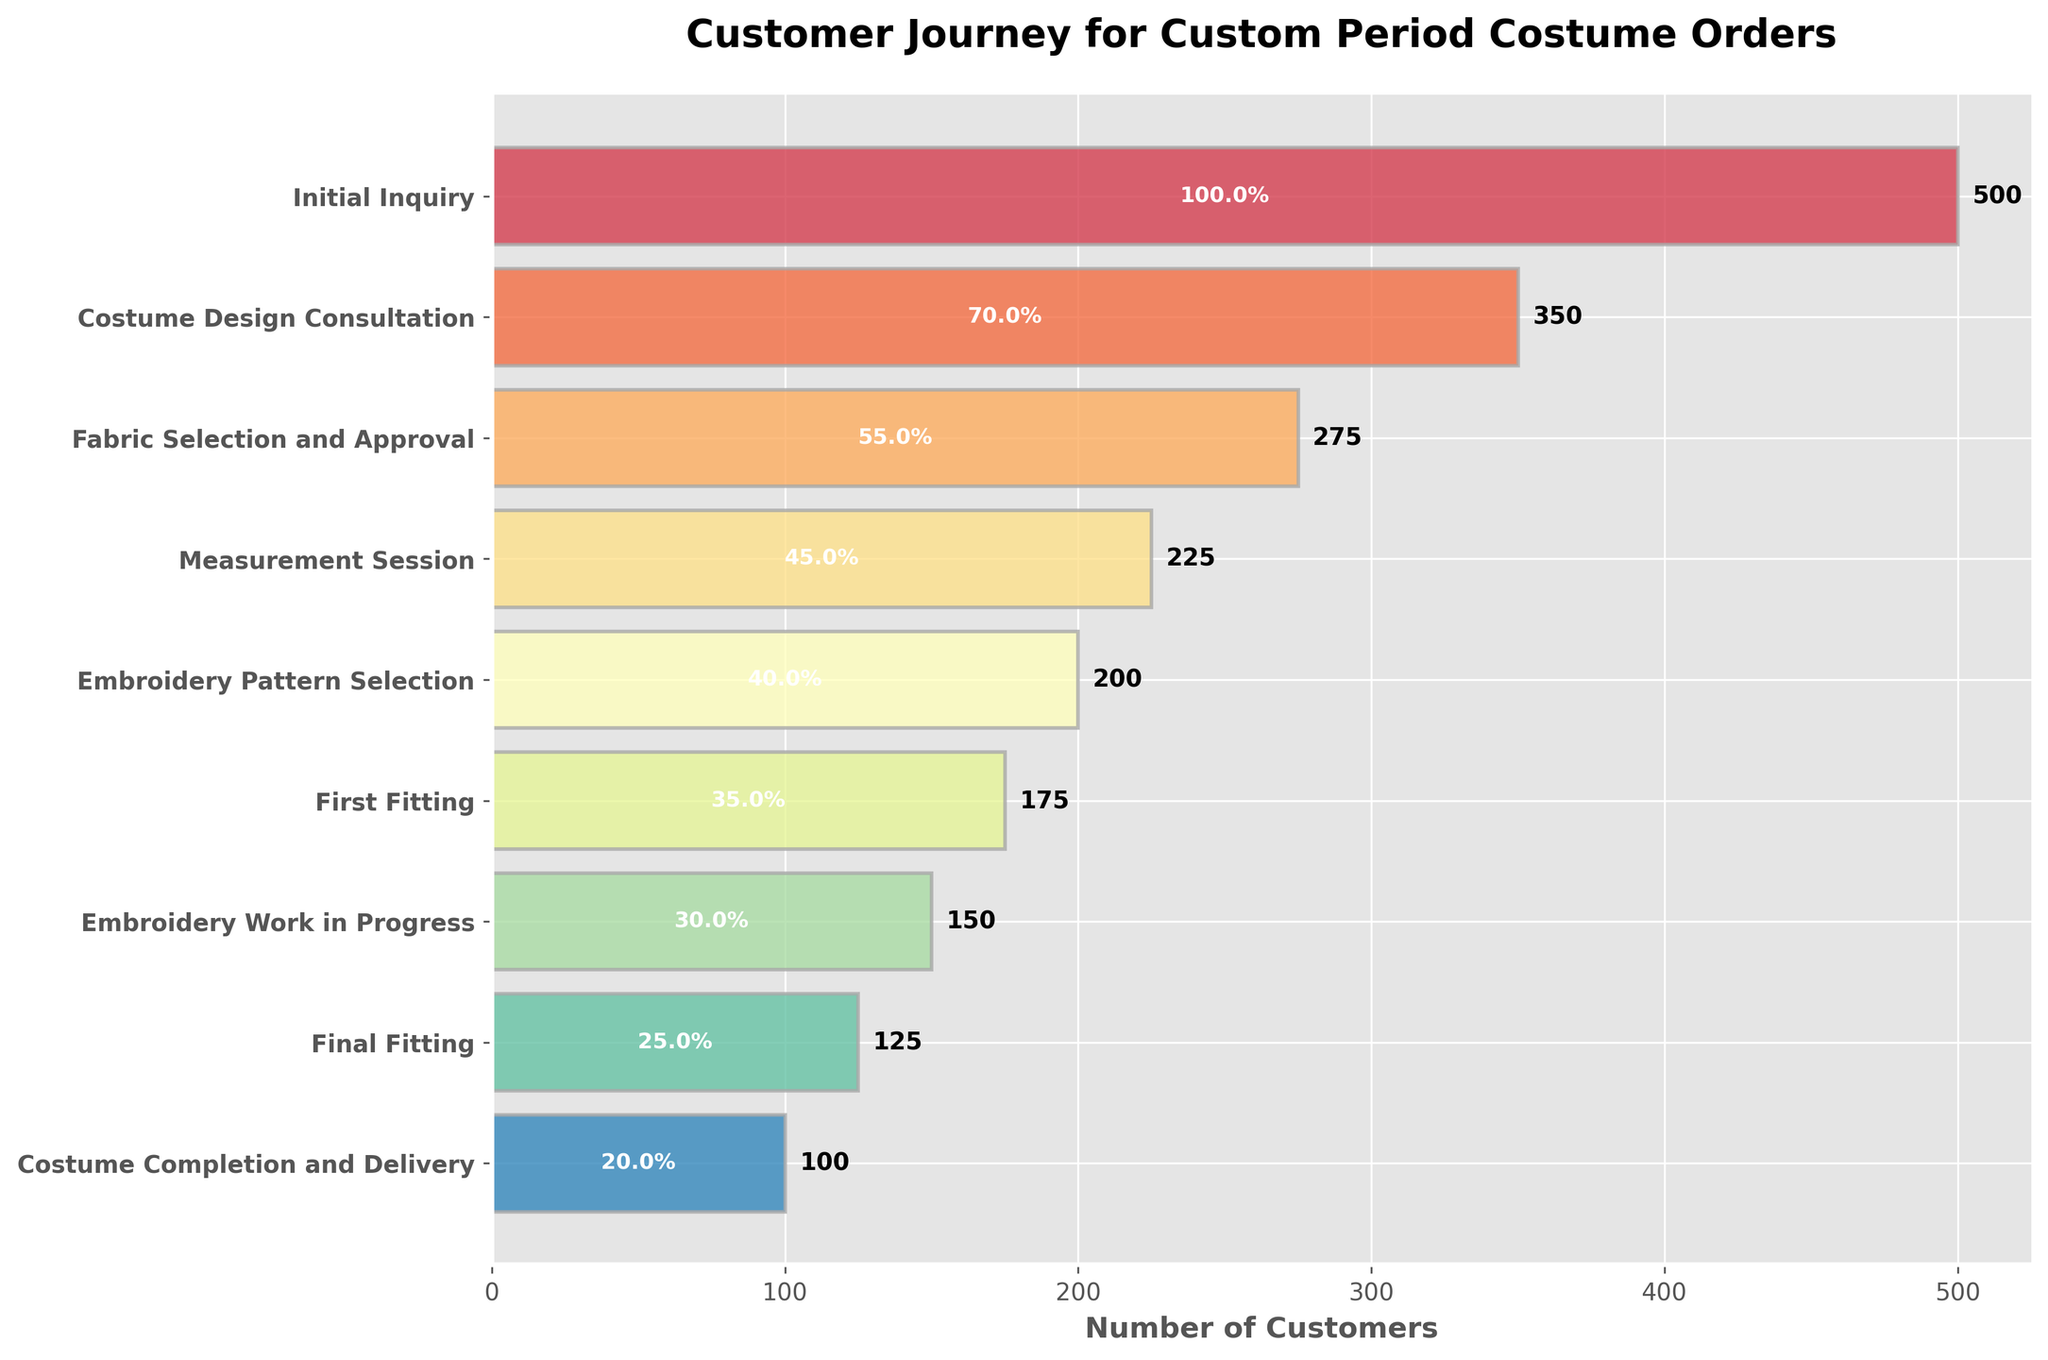What is the title of the figure? The title of the figure is displayed at the top and generally provides a summary of what the chart represents. In this case, it states "Customer Journey for Custom Period Costume Orders," indicating the stages of ordering a custom period costume.
Answer: Customer Journey for Custom Period Costume Orders How many stages are there in the customer journey? Count the number of bars (or stages) listed on the y-axis of the plot to determine the total number of stages in the customer journey.
Answer: 9 What is the smallest number of customers at any stage, and which stage does this correspond to? Identify the stage with the smallest bar length on the x-axis; the label next to it corresponds to the stage. The smallest number of customers is the value next to it.
Answer: 100, Costume Completion and Delivery How many customers drop off between the "Initial Inquiry" stage and the "Costume Design Consultation" stage? Subtract the number of customers in the "Costume Design Consultation" stage from the number of customers in the "Initial Inquiry" stage to calculate the drop-off.
Answer: 150 Which two stages have the highest number of customers? Identify the two stages with the longest horizontal bars (highest numbers) from the y-axis labels. These correspond to the stages with the highest number of customers.
Answer: Initial Inquiry and Costume Design Consultation What percentage of customers who made an Initial Inquiry also reached the "Costume Completion and Delivery" stage? Divide the number of customers in the "Costume Completion and Delivery" stage by the number of customers in the "Initial Inquiry" stage, then multiply by 100 to get the percentage.
Answer: 20% What stage do the customers experience the largest drop in number, and what is the drop? Find the two consecutive stages with the largest difference in the number of customers by comparing the heights of the bars and subtracting the values.
Answer: Initial Inquiry to Costume Design Consultation, 150 drop What is the average number of customers across all stages? Add the number of customers at each stage and then divide by the total number of stages to find the average.
Answer: 233.3 Compare the number of customers in the "First Fitting" stage to those in the "Embroidery Work in Progress" stage: which is higher and by how much? Subtract the number of customers in the "Embroidery Work in Progress" stage from the number in the "First Fitting" stage.
Answer: First Fitting, 25 more Which stage has 125 customers? Identify the stage label next to the bar that aligns with the value of 125 on the x-axis.
Answer: Final Fitting 